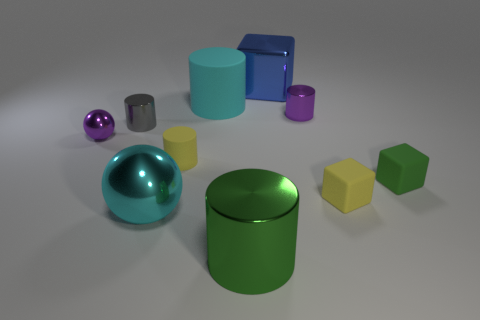Can you describe the material properties of the objects based on their appearance? Certainly! The objects appear to have different material finishes. The cylinders and cubes exhibit a matte finish, which diffuses light evenly across their surfaces, whereas the spheres have a reflective, shiny finish that mirrors their surroundings and adds a sense of depth to their appearance. 